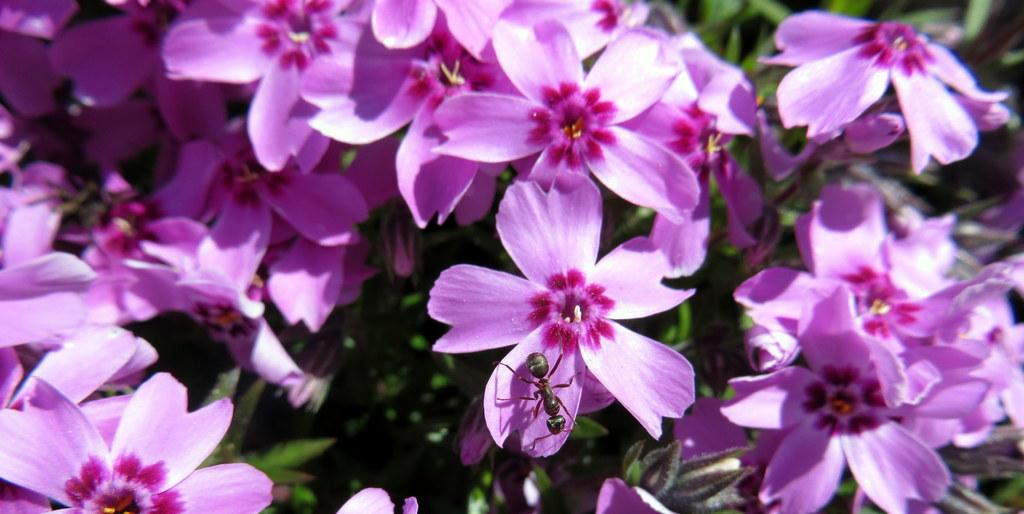What type of flowers are present in the image? There are pink flowers in the image. What small creature can be seen in the image? There is an ant in the image. What can be seen in the background of the image? There are leaves visible in the background of the image. What type of bone can be seen in the image? There is no bone present in the image; it features pink flowers and an ant. 